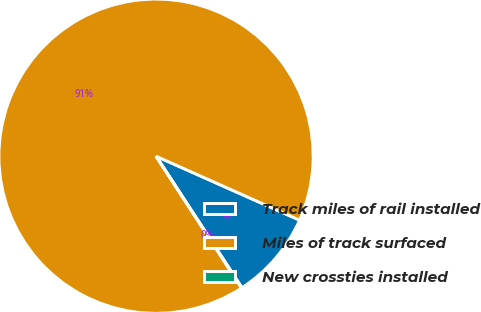Convert chart. <chart><loc_0><loc_0><loc_500><loc_500><pie_chart><fcel>Track miles of rail installed<fcel>Miles of track surfaced<fcel>New crossties installed<nl><fcel>9.12%<fcel>90.83%<fcel>0.05%<nl></chart> 